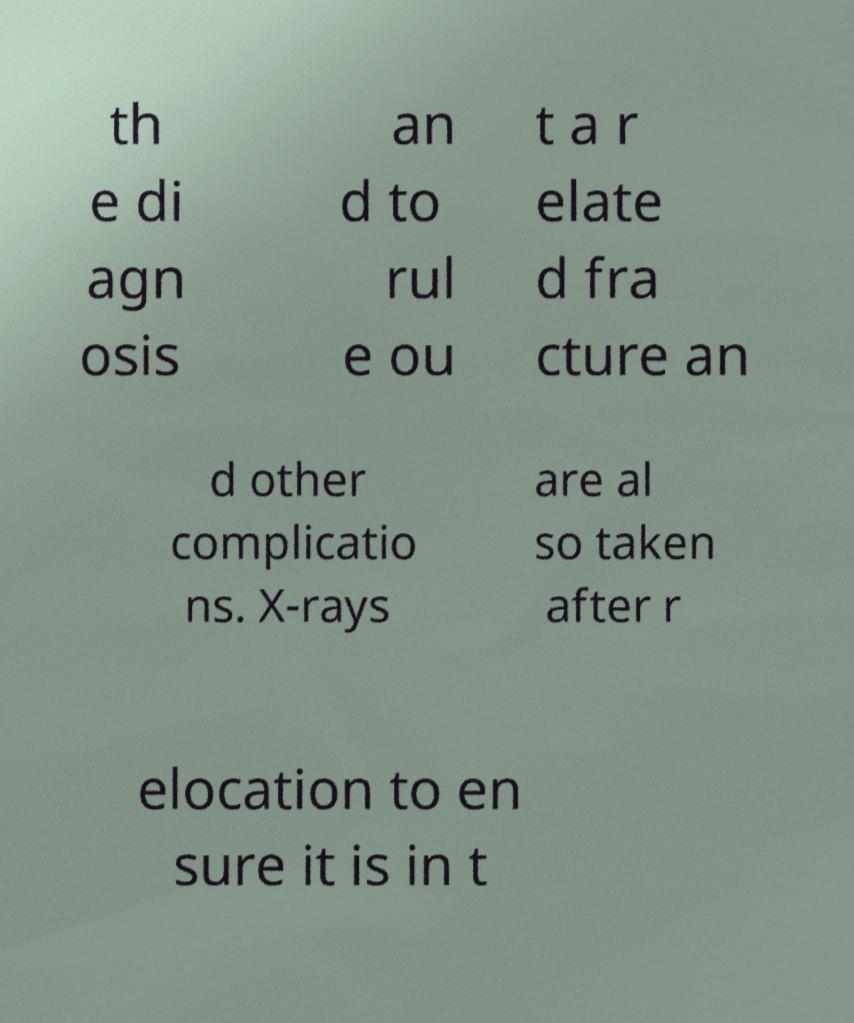Please read and relay the text visible in this image. What does it say? th e di agn osis an d to rul e ou t a r elate d fra cture an d other complicatio ns. X-rays are al so taken after r elocation to en sure it is in t 